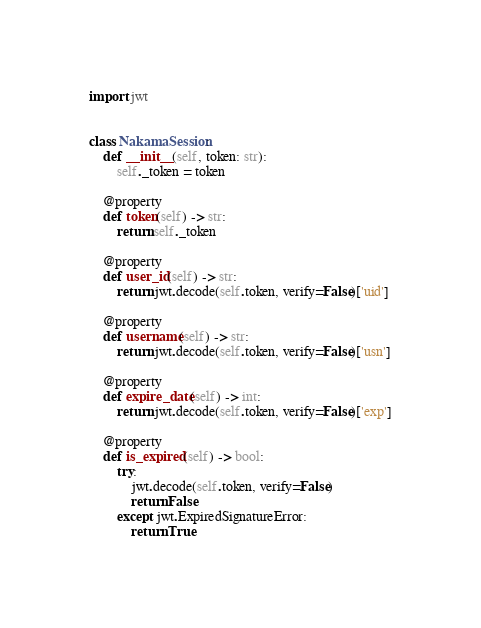Convert code to text. <code><loc_0><loc_0><loc_500><loc_500><_Python_>import jwt


class NakamaSession:
    def __init__(self, token: str):
        self._token = token

    @property
    def token(self) -> str:
        return self._token

    @property
    def user_id(self) -> str:
        return jwt.decode(self.token, verify=False)['uid']

    @property
    def username(self) -> str:
        return jwt.decode(self.token, verify=False)['usn']

    @property
    def expire_date(self) -> int:
        return jwt.decode(self.token, verify=False)['exp']

    @property
    def is_expired(self) -> bool:
        try:
            jwt.decode(self.token, verify=False)
            return False
        except jwt.ExpiredSignatureError:
            return True
</code> 